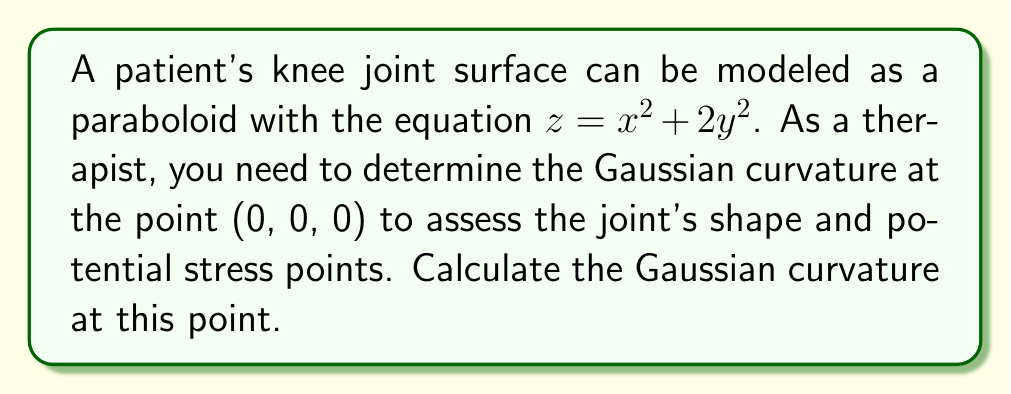Could you help me with this problem? To find the Gaussian curvature of the surface $z = f(x,y) = x^2 + 2y^2$ at the point (0, 0, 0), we'll follow these steps:

1) The Gaussian curvature K is given by:
   $$K = \frac{f_{xx}f_{yy} - f_{xy}^2}{(1 + f_x^2 + f_y^2)^2}$$

2) Calculate the partial derivatives:
   $f_x = 2x$
   $f_y = 4y$
   $f_{xx} = 2$
   $f_{yy} = 4$
   $f_{xy} = 0$

3) Evaluate these at the point (0, 0, 0):
   $f_x(0,0) = 0$
   $f_y(0,0) = 0$
   $f_{xx}(0,0) = 2$
   $f_{yy}(0,0) = 4$
   $f_{xy}(0,0) = 0$

4) Substitute into the Gaussian curvature formula:
   $$K = \frac{(2)(4) - (0)^2}{(1 + 0^2 + 0^2)^2} = \frac{8}{1^2} = 8$$

Therefore, the Gaussian curvature at the point (0, 0, 0) is 8.
Answer: 8 